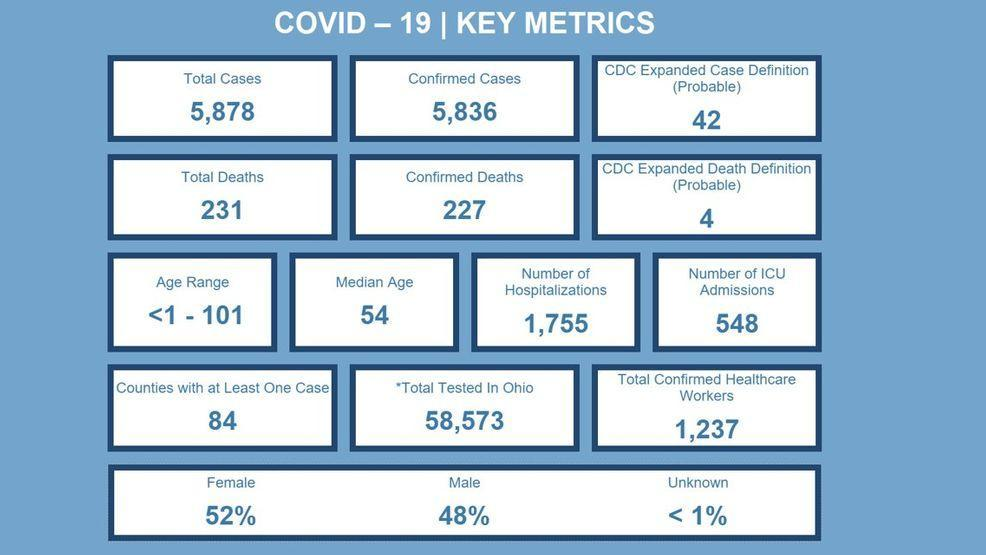What is the total number of COVID-19 cases?
Answer the question with a short phrase. 5,878 What is the number of hospitalizations reported? 1,755 What percentage of females are covid positive? 52% What is the total number of people tested for COVID-19 in Ohio? 58,573 What is the total number of COVID-19 deaths? 231 What is the number of confirmed COVID-19 deaths? 227 What percentage of males are covid positive? 48% 